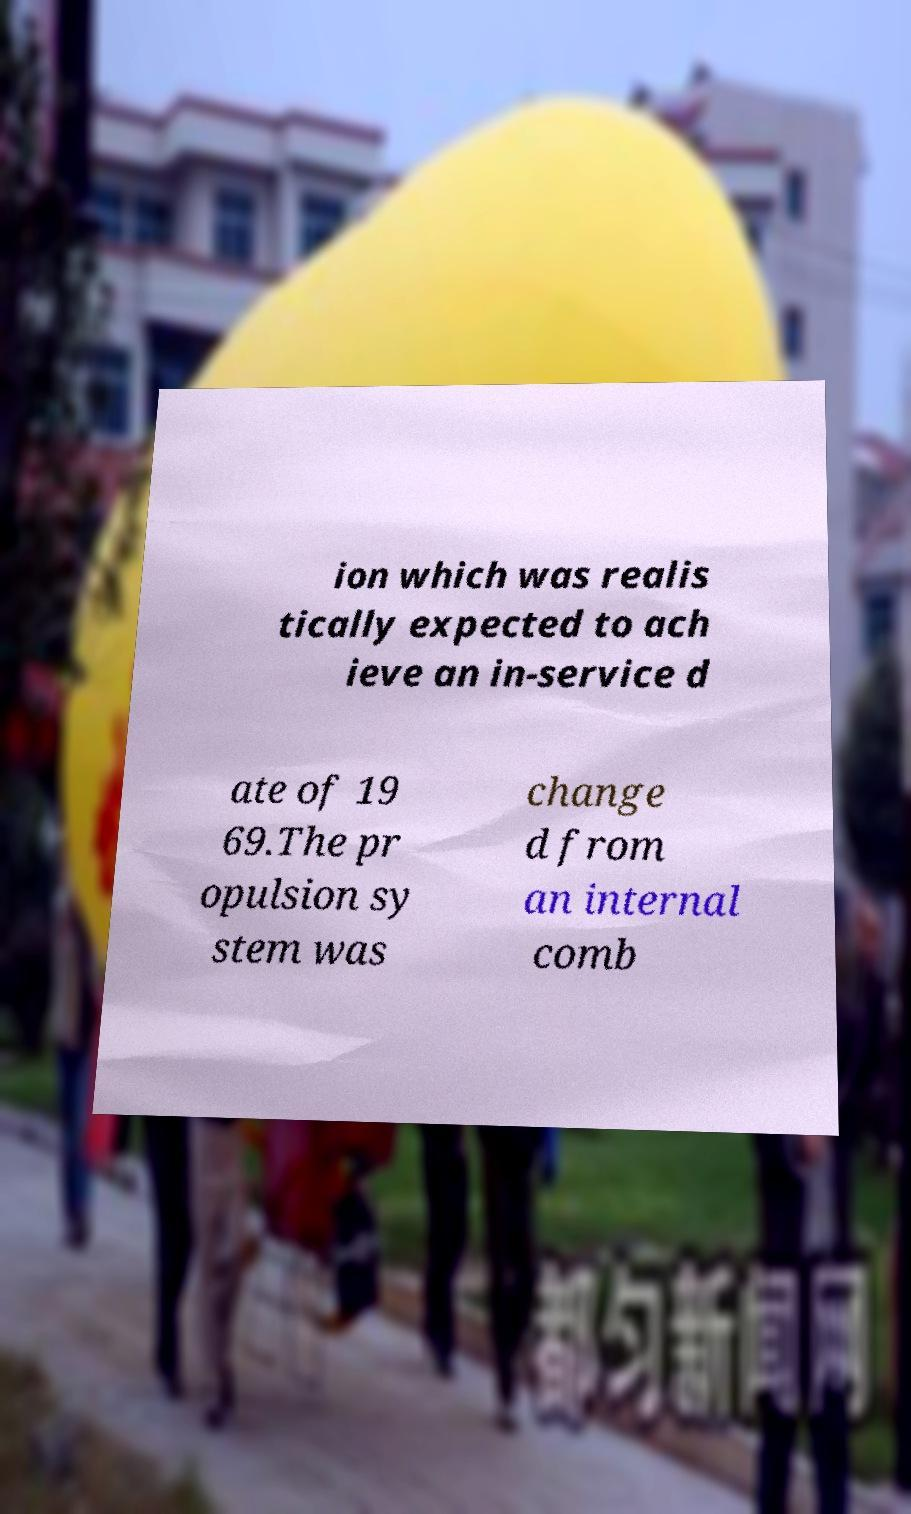There's text embedded in this image that I need extracted. Can you transcribe it verbatim? ion which was realis tically expected to ach ieve an in-service d ate of 19 69.The pr opulsion sy stem was change d from an internal comb 